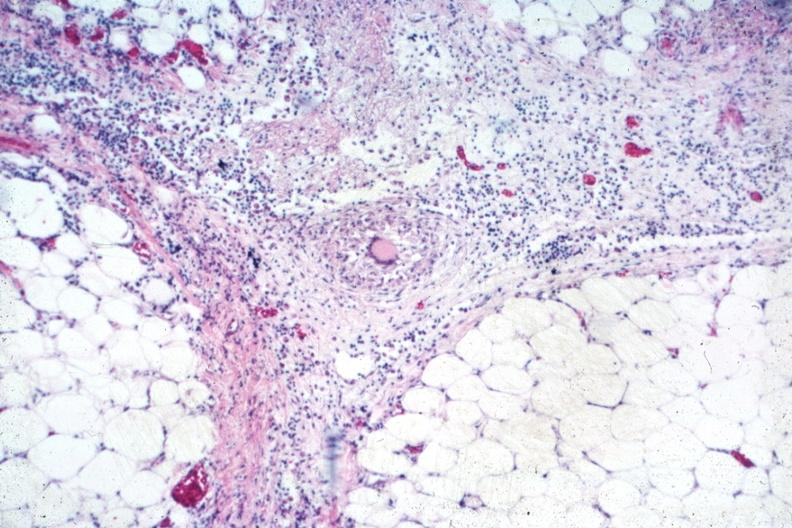what is present?
Answer the question using a single word or phrase. Tuberculosis 